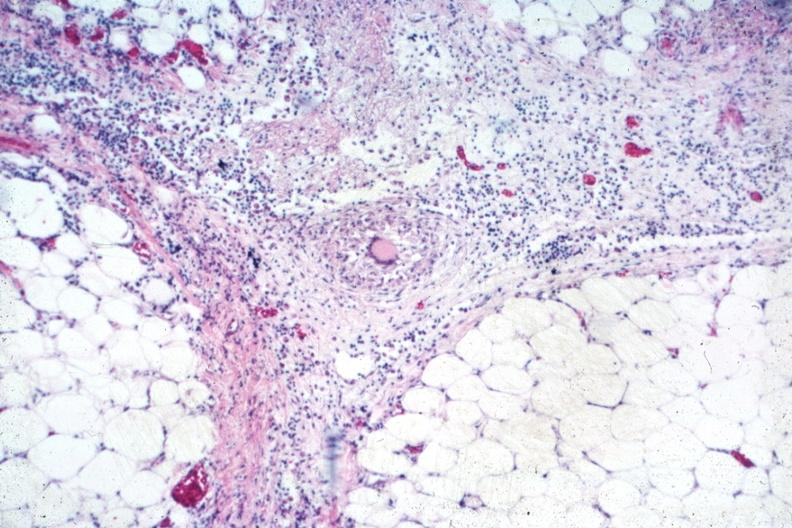what is present?
Answer the question using a single word or phrase. Tuberculosis 